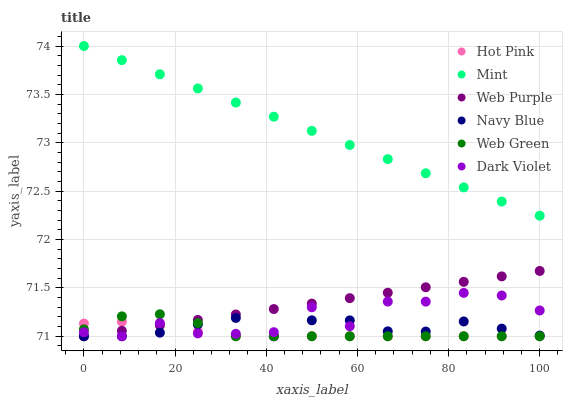Does Hot Pink have the minimum area under the curve?
Answer yes or no. Yes. Does Mint have the maximum area under the curve?
Answer yes or no. Yes. Does Dark Violet have the minimum area under the curve?
Answer yes or no. No. Does Dark Violet have the maximum area under the curve?
Answer yes or no. No. Is Mint the smoothest?
Answer yes or no. Yes. Is Dark Violet the roughest?
Answer yes or no. Yes. Is Hot Pink the smoothest?
Answer yes or no. No. Is Hot Pink the roughest?
Answer yes or no. No. Does Navy Blue have the lowest value?
Answer yes or no. Yes. Does Mint have the lowest value?
Answer yes or no. No. Does Mint have the highest value?
Answer yes or no. Yes. Does Dark Violet have the highest value?
Answer yes or no. No. Is Navy Blue less than Mint?
Answer yes or no. Yes. Is Mint greater than Web Green?
Answer yes or no. Yes. Does Web Green intersect Web Purple?
Answer yes or no. Yes. Is Web Green less than Web Purple?
Answer yes or no. No. Is Web Green greater than Web Purple?
Answer yes or no. No. Does Navy Blue intersect Mint?
Answer yes or no. No. 